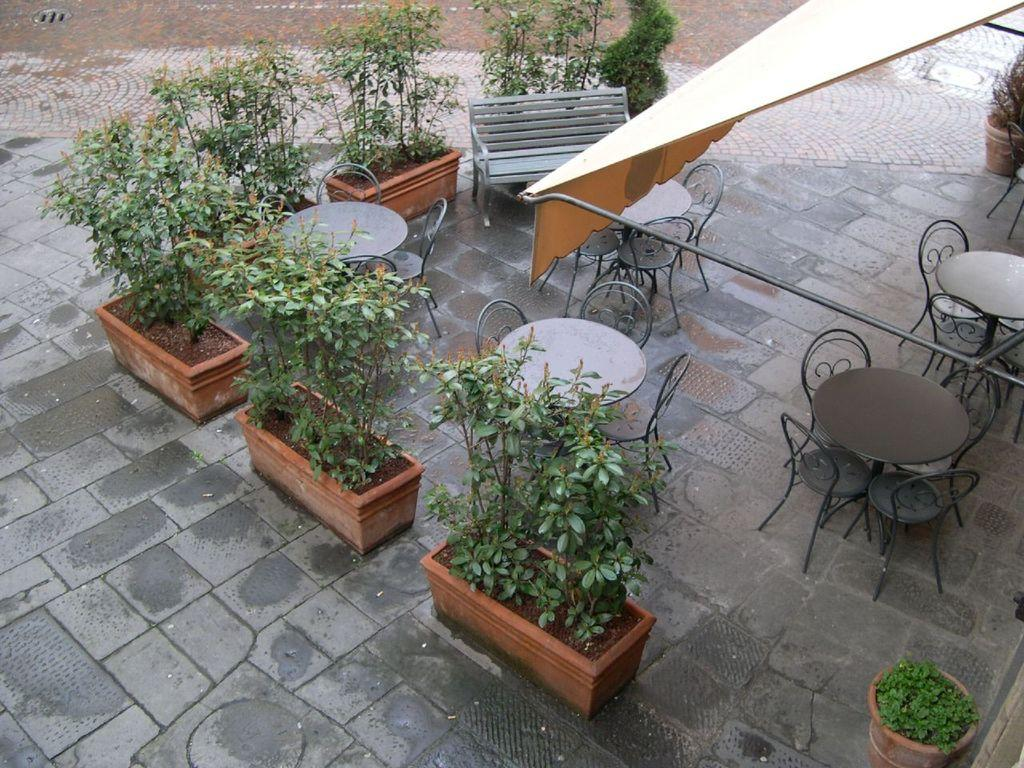What type of objects can be seen in the image related to gardening? There are flower pots in the image. What type of outdoor furniture is present in the image? There is a bench, tables, and chairs in the image. What is the condition of the road in the image? There is water on the road in the image. What year is depicted in the image? The year is not depicted in the image; it is a timeless scene. Is there an alley visible in the image? There is no alley present in the image. What type of hat is worn by the chairs in the image? The chairs in the image do not have hats; they are simply chairs. 